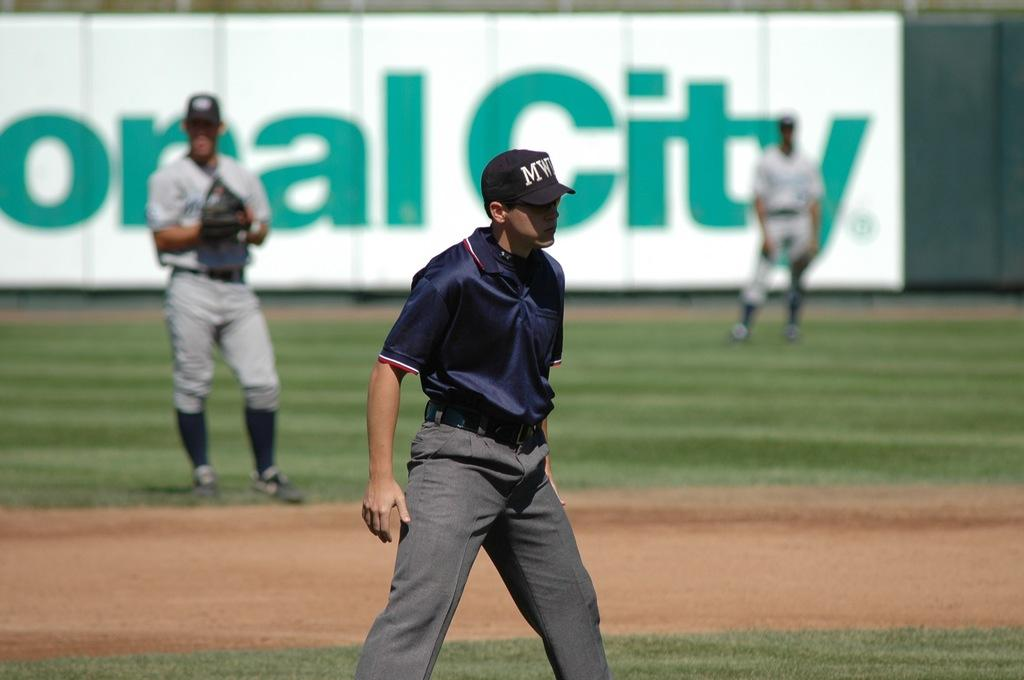<image>
Offer a succinct explanation of the picture presented. A baseball umpire is standing on a field in front of a Coral City sign. 